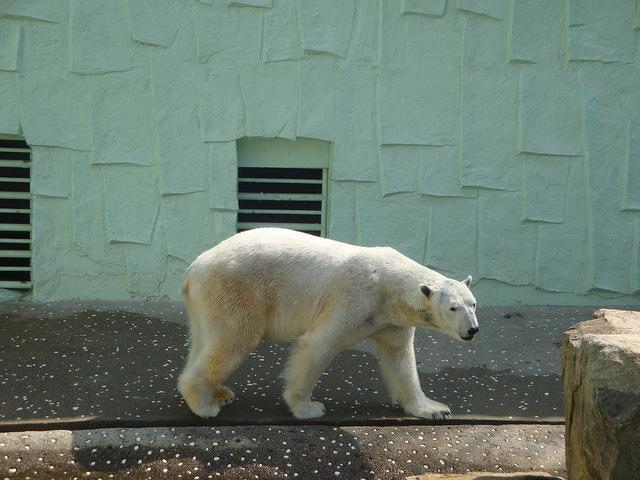How many polar bears are there?
Give a very brief answer. 1. 